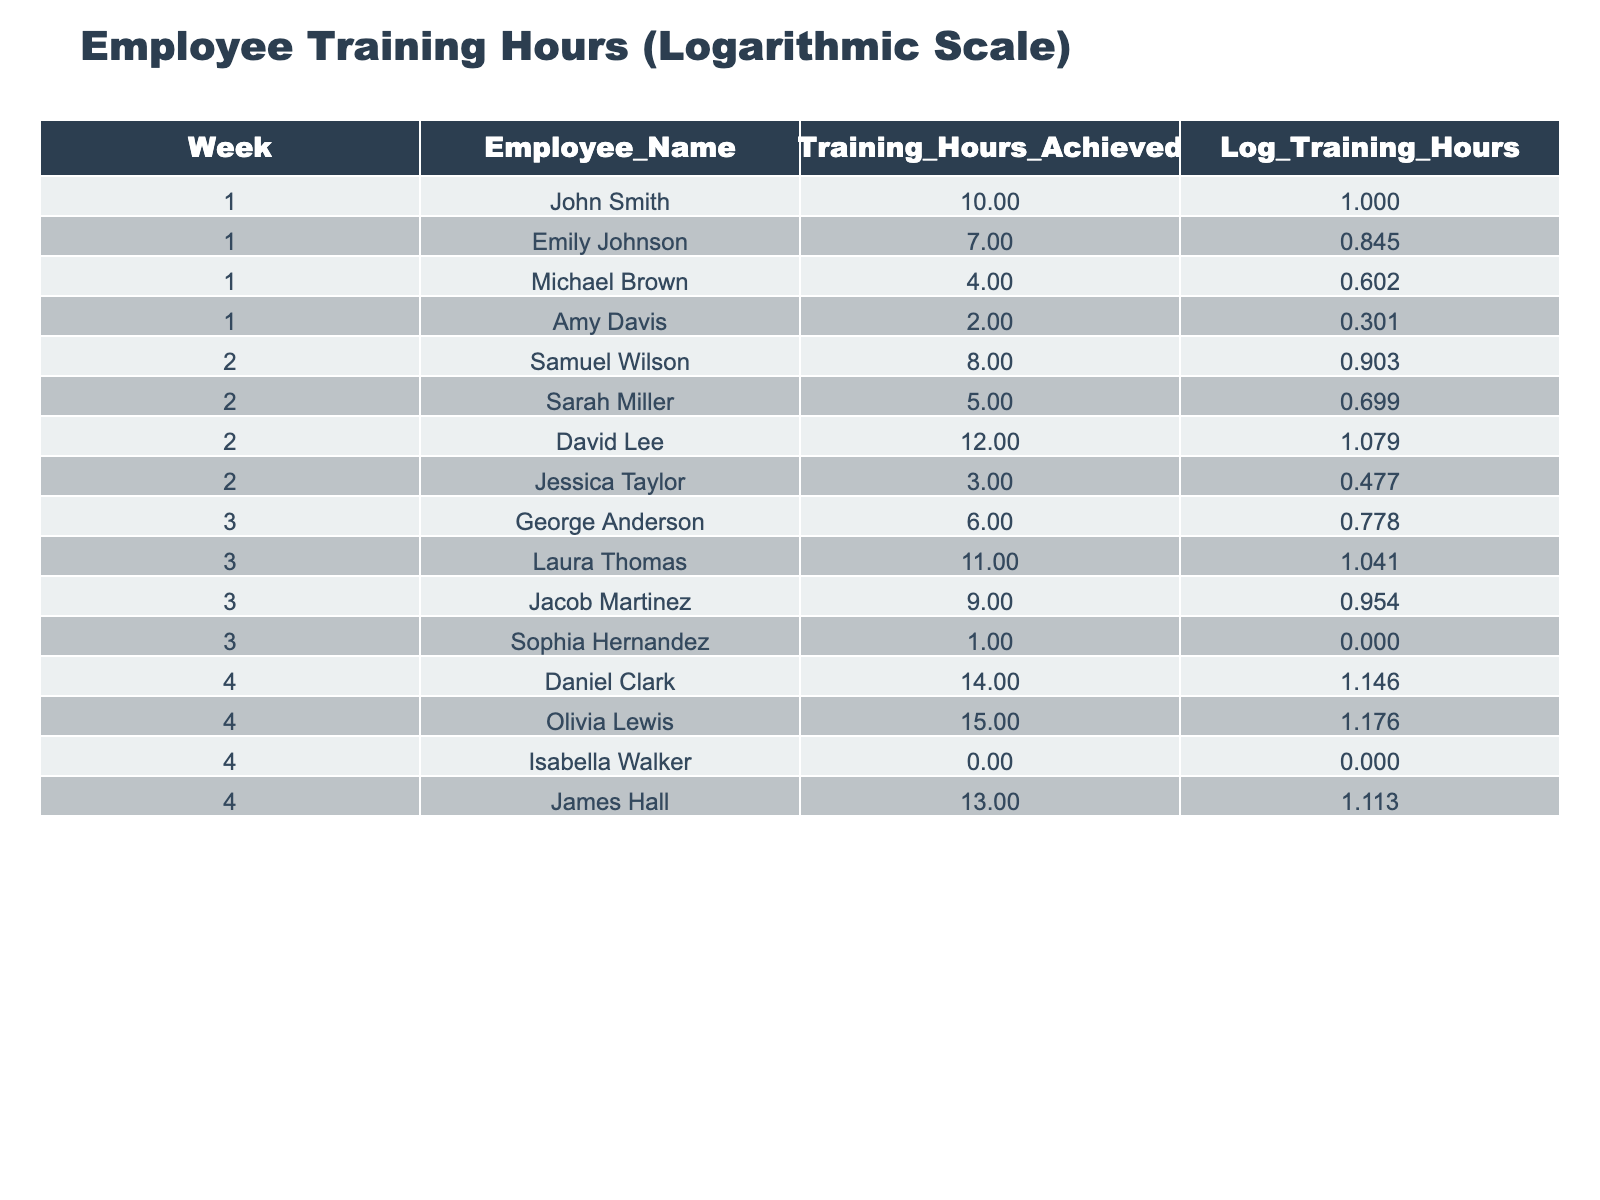What were the training hours achieved by Olivia Lewis in week 4? According to the table, the training hours achieved by Olivia Lewis in week 4 is listed as 15 hours.
Answer: 15 Which employee achieved the highest training hours in week 2? In week 2, David Lee achieved the highest training hours, as indicated by the value of 12 hours in the table.
Answer: David Lee What is the average training hours achieved by employees in week 1? To find the average, we sum the training hours from week 1 (10 + 7 + 4 + 2 = 23) and divide by the number of employees (4), resulting in an average of 23 / 4 = 5.75.
Answer: 5.75 Did any employee record zero training hours? Yes, Isabella Walker recorded zero training hours, which is explicitly stated in the table for week 4.
Answer: Yes Which week had the highest total training hours achieved by employees and what was that total? We need to sum the training hours for each week: Week 1 (10 + 7 + 4 + 2 = 23), Week 2 (8 + 5 + 12 + 3 = 28), Week 3 (6 + 11 + 9 + 1 = 27), and Week 4 (14 + 15 + 0 + 13 = 42). Since week 4 has the highest sum of 42, that is the answer.
Answer: Week 4, total 42 What is the difference between the training hours achieved by John Smith and Michael Brown in week 1? John Smith achieved 10 hours and Michael Brown achieved 4 hours in week 1. The difference is calculated as 10 - 4 = 6 hours.
Answer: 6 How many employees achieved more than 10 training hours in week 3? In week 3, Laura Thomas achieved 11 hours, and Jacob Martinez achieved 9 hours. However, only Laura exceeds 10 hours. Therefore, there is 1 employee.
Answer: 1 What was the logarithmic value of training hours achieved by Sarah Miller in week 2? The table lists Sarah Miller’s logarithmic training hours for week 2 as 0.699, which corresponds to her training hours of 5.
Answer: 0.699 